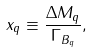<formula> <loc_0><loc_0><loc_500><loc_500>x _ { q } \equiv \frac { \Delta M _ { q } } { \Gamma _ { B _ { q } } } ,</formula> 